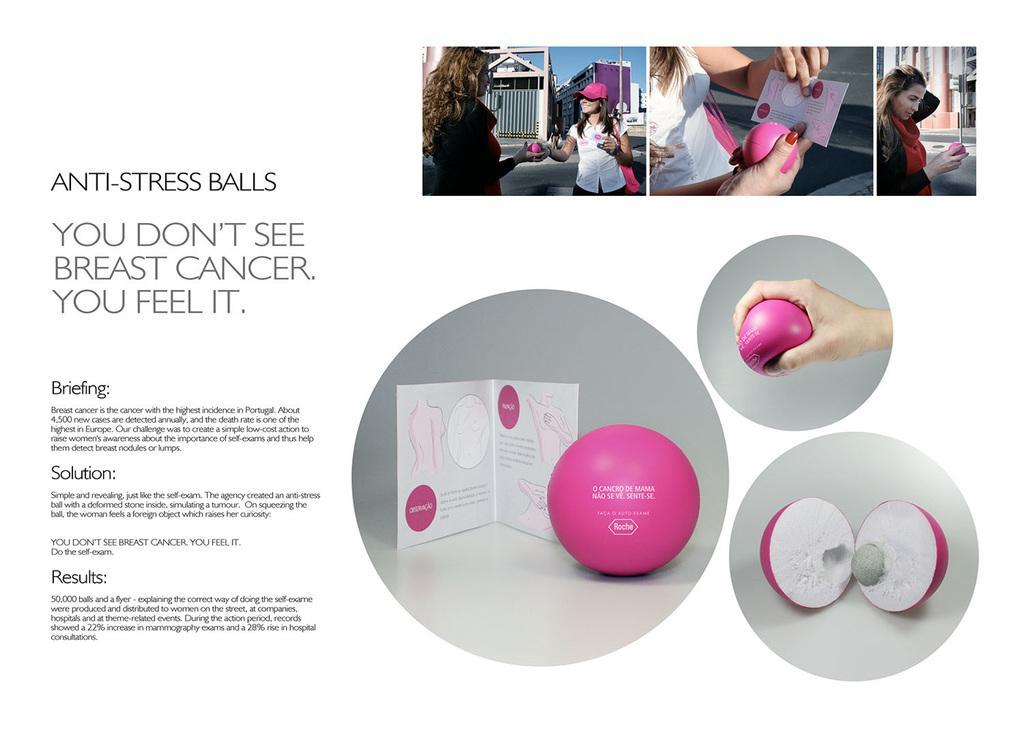Can you describe this image briefly? Here, we can see a slide with different collages of photos and we can see some text. 